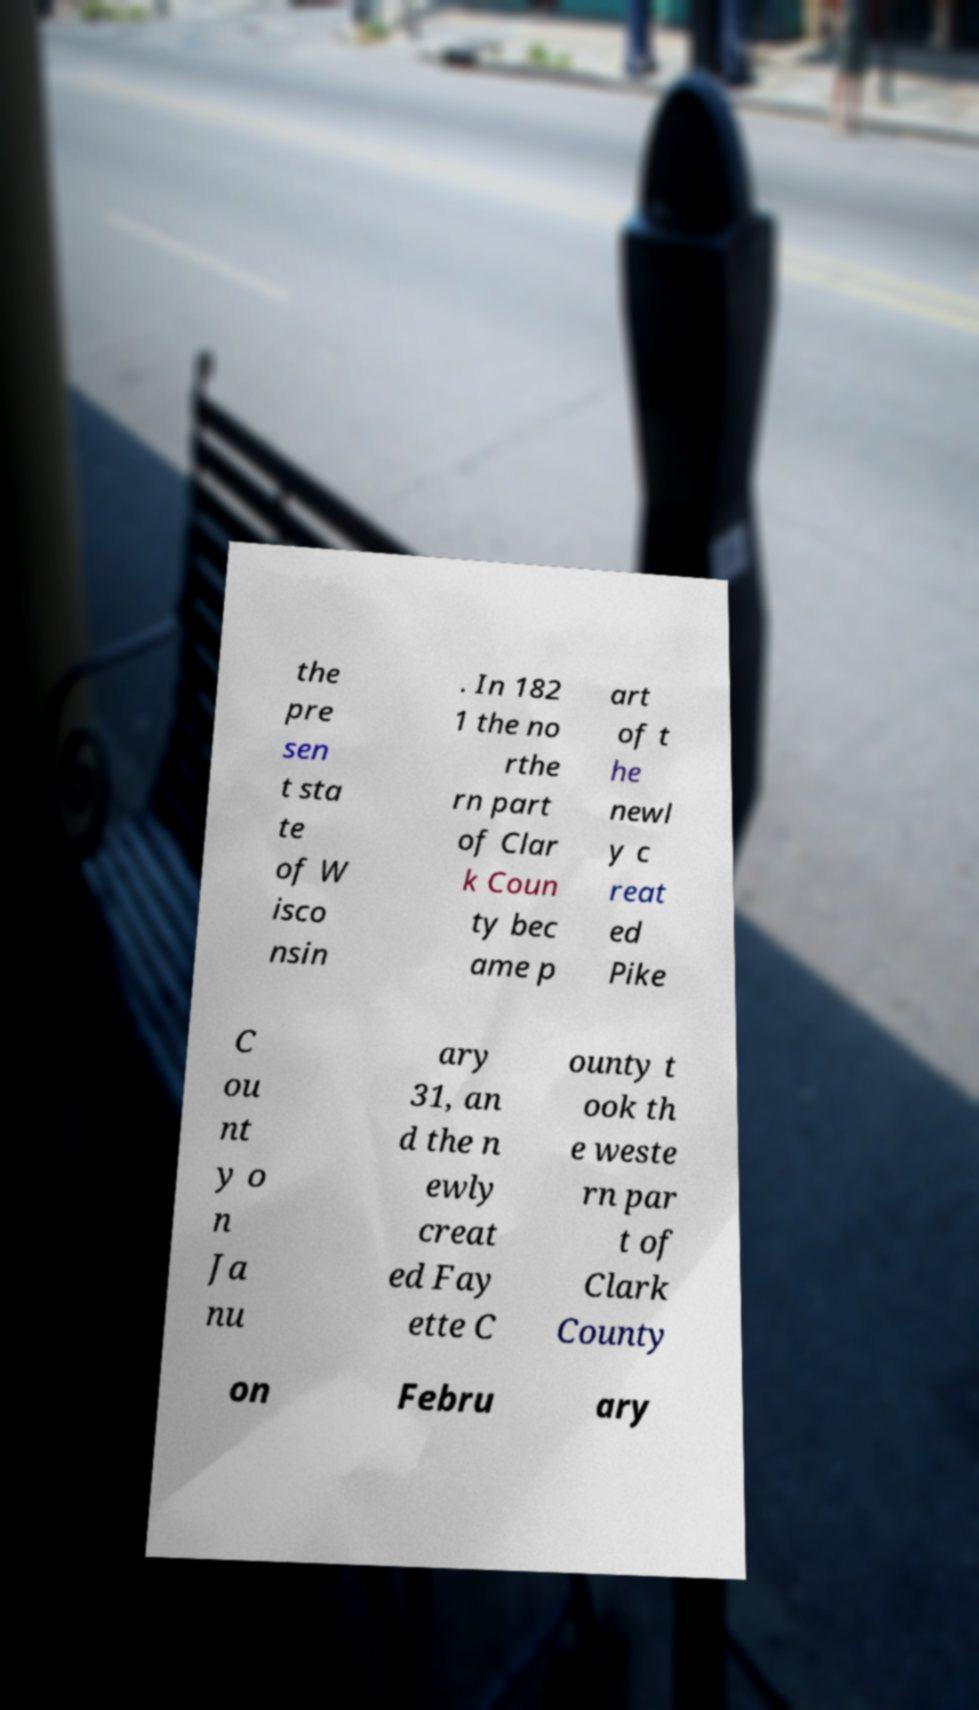Please identify and transcribe the text found in this image. the pre sen t sta te of W isco nsin . In 182 1 the no rthe rn part of Clar k Coun ty bec ame p art of t he newl y c reat ed Pike C ou nt y o n Ja nu ary 31, an d the n ewly creat ed Fay ette C ounty t ook th e weste rn par t of Clark County on Febru ary 